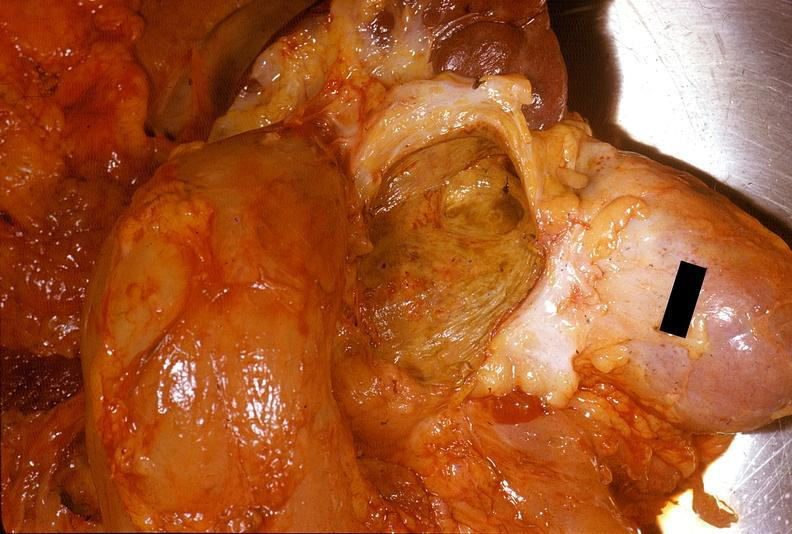does this image show chronic pancreatitis with cyst formation?
Answer the question using a single word or phrase. Yes 